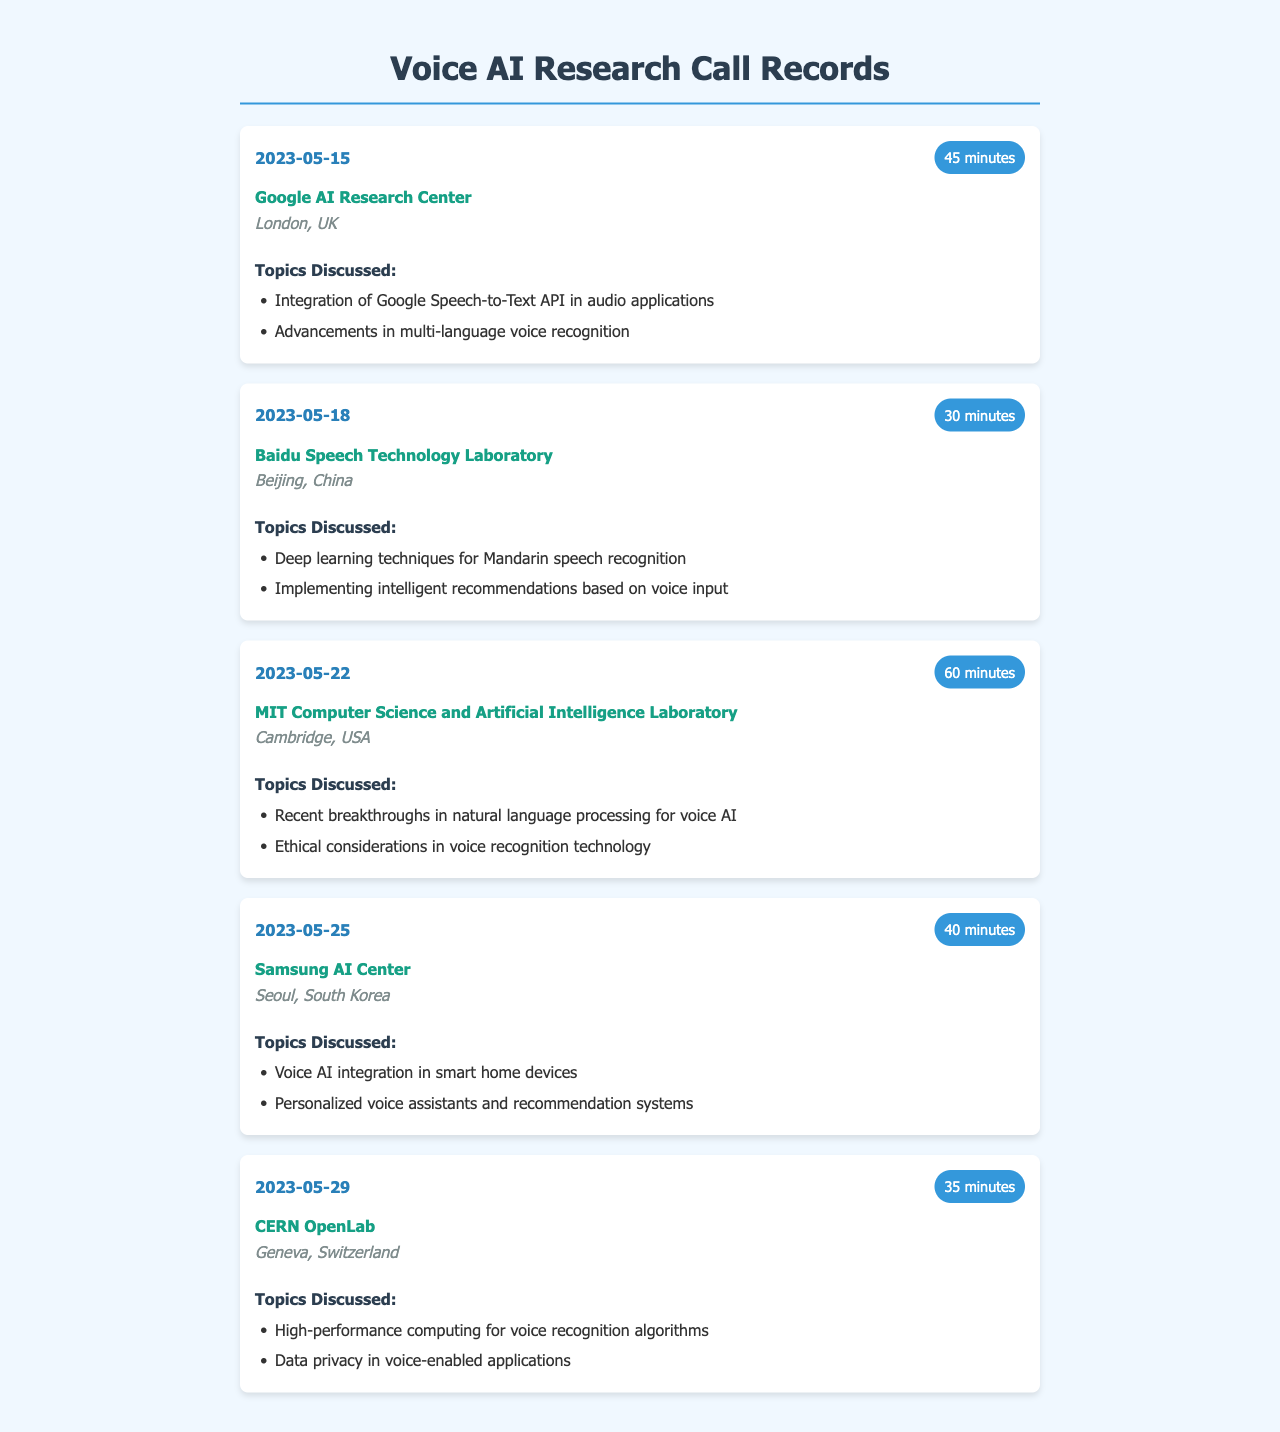What is the duration of the call to Google AI Research Center? The duration of the call to Google AI Research Center is listed under the "call-duration" class for the specified record.
Answer: 45 minutes Which location hosts Baidu Speech Technology Laboratory? The location is provided in the "location" field of the record for Baidu Speech Technology Laboratory.
Answer: Beijing, China What date was the call to MIT Computer Science and Artificial Intelligence Laboratory made? The date can be found in the "call-date" section for the MIT call record.
Answer: 2023-05-22 How many minutes was the call to Samsung AI Center? The total minutes for the call to Samsung AI Center can be located in the "call-duration" information.
Answer: 40 minutes What topic was discussed in the call with CERN OpenLab? Topics discussed are listed under the "topics" section of the call record for CERN OpenLab.
Answer: High-performance computing for voice recognition algorithms Which research center was involved in discussing deep learning techniques for Mandarin speech recognition? The associated call record specifies the research center in relation to the mentioned topic.
Answer: Baidu Speech Technology Laboratory What is the total number of calls made during May 2023? The number of calls can be determined by counting each call record in the document for May 2023.
Answer: 5 What is one ethical consideration discussed in the MIT call? The specific ethical consideration is provided within the topics listed under the MIT call record.
Answer: Ethical considerations in voice recognition technology 